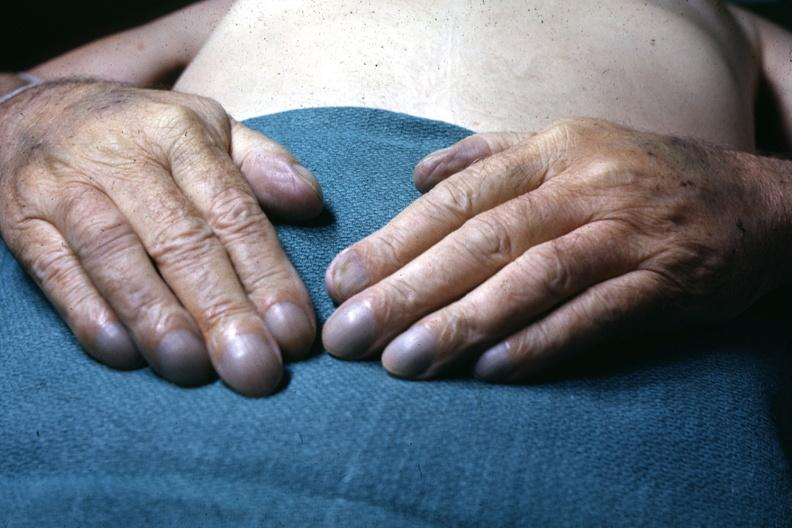what are present?
Answer the question using a single word or phrase. Extremities 